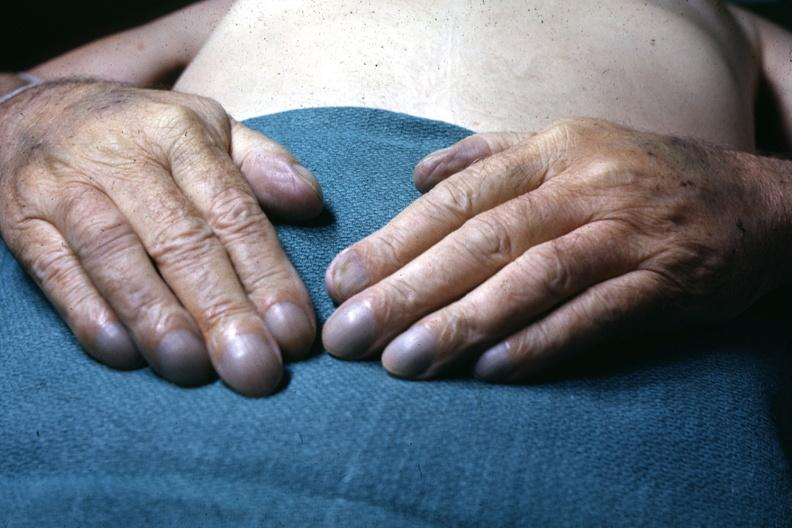what are present?
Answer the question using a single word or phrase. Extremities 